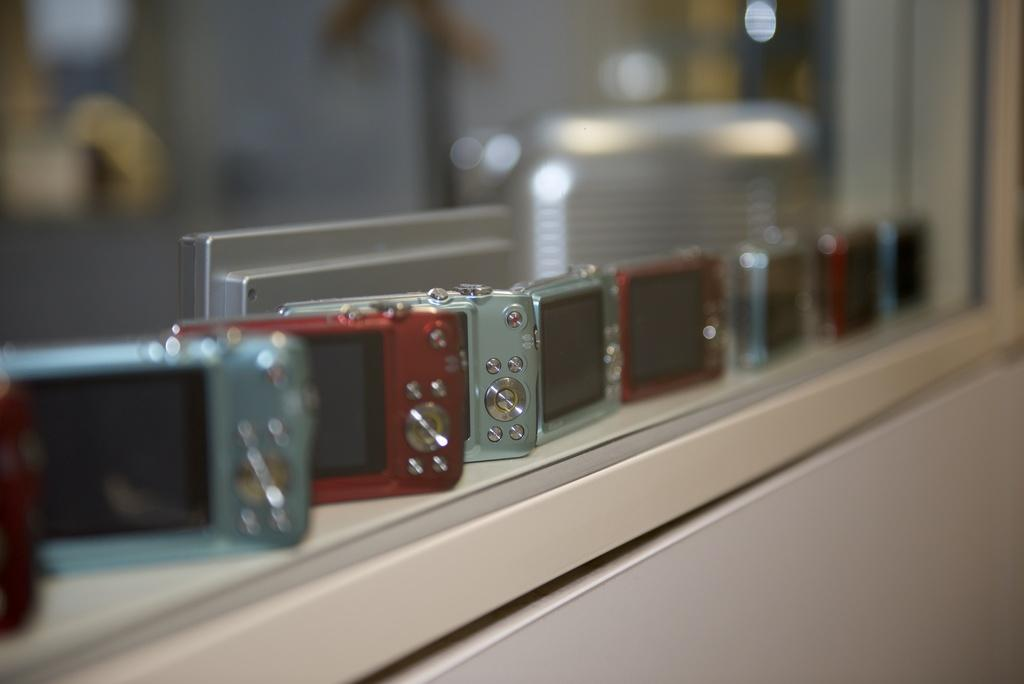What is the main subject of the image? The main subject of the image is an object with devices placed on it in the center. Can you describe the background of the image? The background of the image is blurry. Are there any other objects visible in the image besides the main subject? Yes, there are other objects visible in the background. What type of dress is the man wearing in the image? There is no man or dress present in the image. Can you describe the veil on the man's head in the image? There is no man or veil present in the image. 